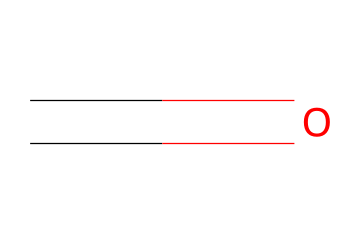What is the chemical name represented by the SMILES? The SMILES notation "C=O" indicates a carbon atom double-bonded to an oxygen atom, which is the characteristic structure of formaldehyde.
Answer: formaldehyde How many carbon atoms are present in the structure? The SMILES shows one carbon atom (C), represented at the beginning of the notation.
Answer: 1 What type of bond is present between carbon and oxygen in this chemical? The "=" sign in the SMILES notation indicates a double bond between the carbon (C) and the oxygen (O) atom.
Answer: double bond Is formaldehyde a solid, liquid, or gas at room temperature? Formaldehyde is commonly encountered as a gas at room temperature, though it can also be found in a liquid form in solutions.
Answer: gas What functional group is present in formaldehyde? The structure features a carbonyl group (C=O), which is characteristic of aldehydes, indicating that formaldehyde belongs to this category.
Answer: carbonyl group What is one primary use of formaldehyde in church disinfectants? Formaldehyde is often used as an antimicrobial agent due to its ability to kill bacteria and fungi, making it a popular choice in disinfectants.
Answer: antimicrobial agent 